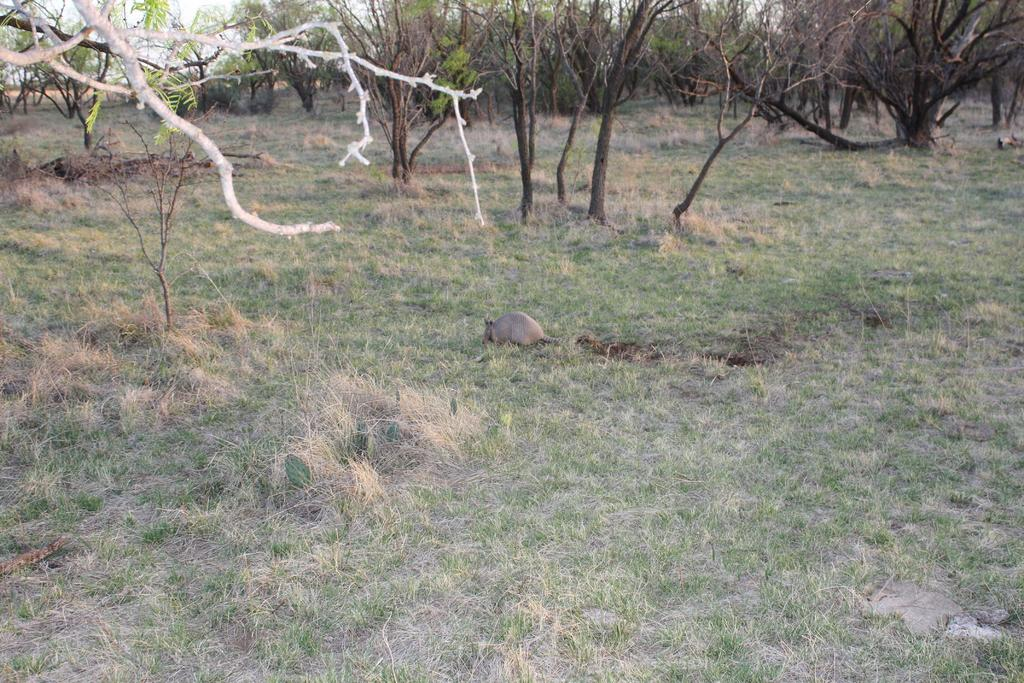What type of creature can be seen in the image? There is an animal in the image. Where is the animal located? The animal is on the ground. What type of vegetation is present in the image? There is dried grass in the image. What other natural elements can be seen in the image? There are trees in the image. What color is the eye of the animal in the image? There is no visible eye in the image, as the animal is not a human or a creature with visible eyes. 